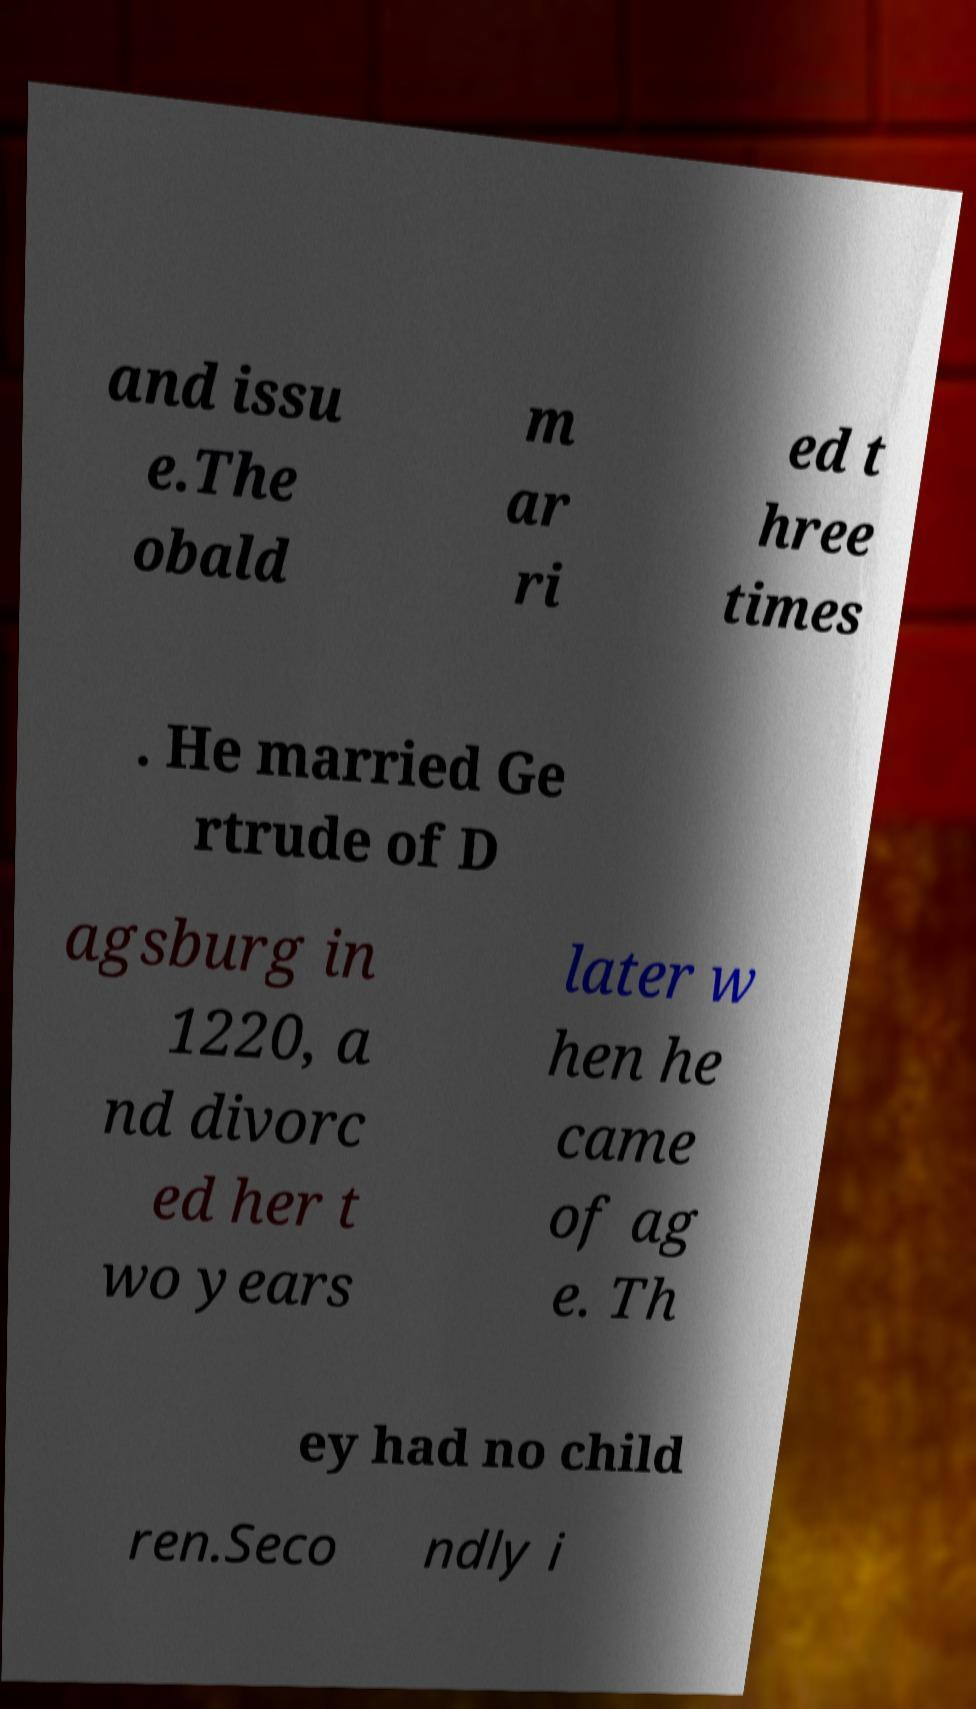What messages or text are displayed in this image? I need them in a readable, typed format. and issu e.The obald m ar ri ed t hree times . He married Ge rtrude of D agsburg in 1220, a nd divorc ed her t wo years later w hen he came of ag e. Th ey had no child ren.Seco ndly i 